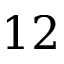<formula> <loc_0><loc_0><loc_500><loc_500>1 2</formula> 